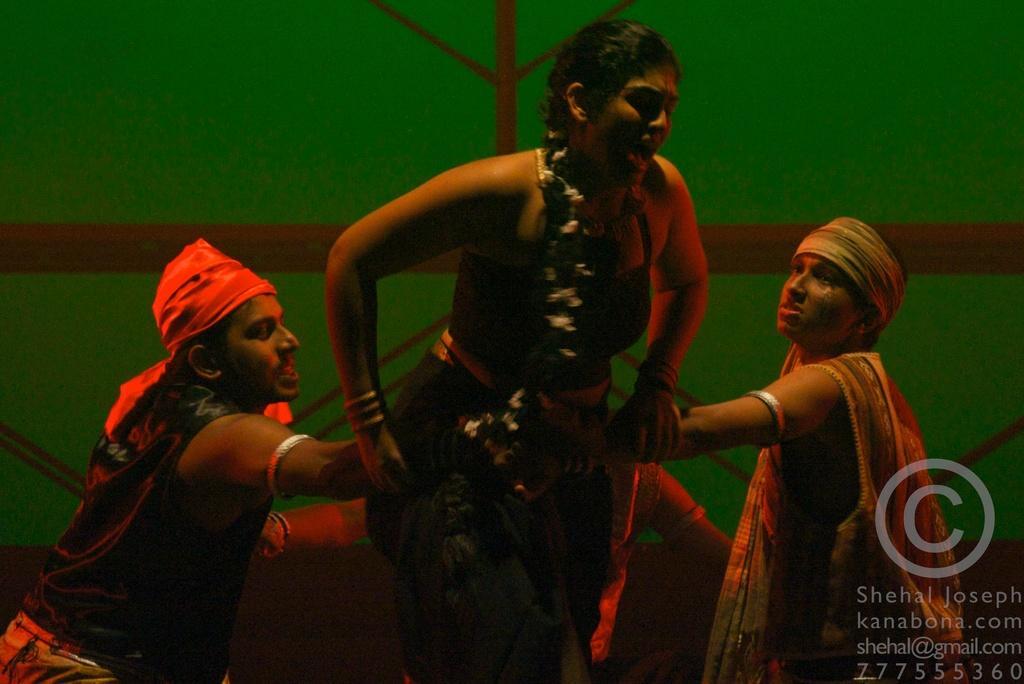In one or two sentences, can you explain what this image depicts? In this image I can see four persons wearing costumes. Three persons are holding their hands and sitting. In the middle of these three persons there is a woman standing. In the background there are few metal rods and a green surface. In the bottom right-hand corner there is some edited text. 